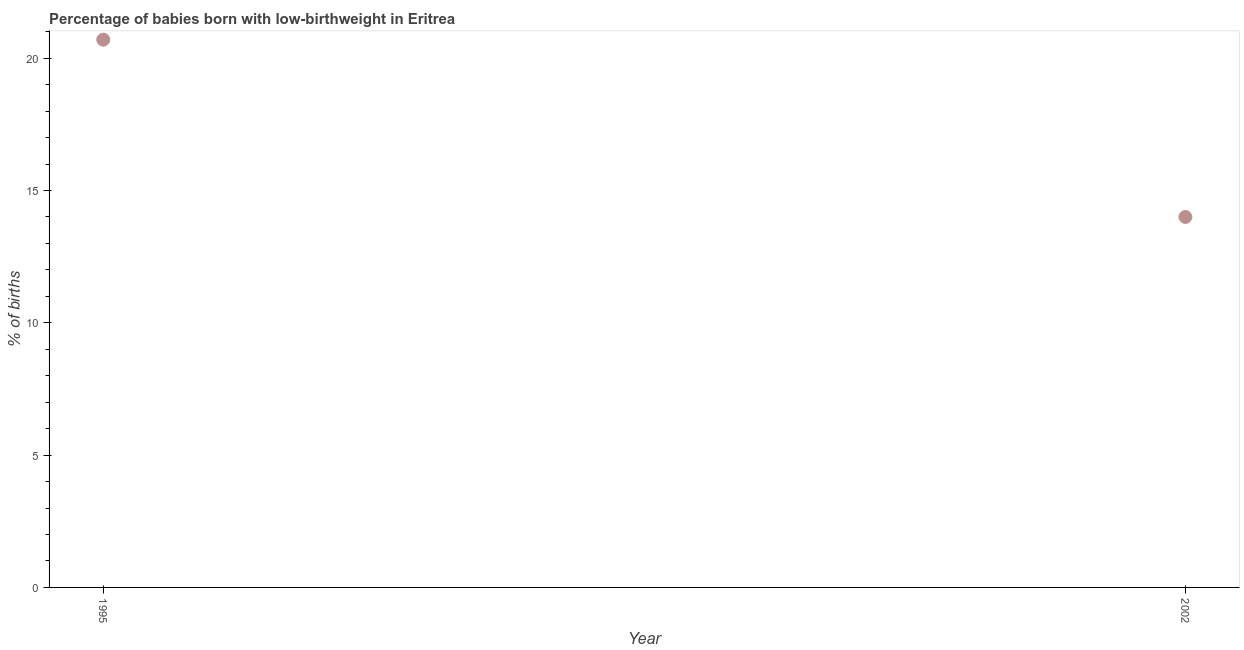What is the percentage of babies who were born with low-birthweight in 1995?
Ensure brevity in your answer.  20.7. Across all years, what is the maximum percentage of babies who were born with low-birthweight?
Offer a very short reply. 20.7. Across all years, what is the minimum percentage of babies who were born with low-birthweight?
Your response must be concise. 14. In which year was the percentage of babies who were born with low-birthweight minimum?
Provide a succinct answer. 2002. What is the sum of the percentage of babies who were born with low-birthweight?
Your response must be concise. 34.7. What is the difference between the percentage of babies who were born with low-birthweight in 1995 and 2002?
Provide a succinct answer. 6.7. What is the average percentage of babies who were born with low-birthweight per year?
Give a very brief answer. 17.35. What is the median percentage of babies who were born with low-birthweight?
Provide a short and direct response. 17.35. In how many years, is the percentage of babies who were born with low-birthweight greater than 11 %?
Provide a succinct answer. 2. Do a majority of the years between 1995 and 2002 (inclusive) have percentage of babies who were born with low-birthweight greater than 16 %?
Provide a short and direct response. No. What is the ratio of the percentage of babies who were born with low-birthweight in 1995 to that in 2002?
Offer a very short reply. 1.48. Is the percentage of babies who were born with low-birthweight in 1995 less than that in 2002?
Provide a succinct answer. No. Does the percentage of babies who were born with low-birthweight monotonically increase over the years?
Ensure brevity in your answer.  No. How many years are there in the graph?
Make the answer very short. 2. What is the difference between two consecutive major ticks on the Y-axis?
Give a very brief answer. 5. Does the graph contain grids?
Ensure brevity in your answer.  No. What is the title of the graph?
Offer a terse response. Percentage of babies born with low-birthweight in Eritrea. What is the label or title of the Y-axis?
Your answer should be very brief. % of births. What is the % of births in 1995?
Give a very brief answer. 20.7. What is the % of births in 2002?
Provide a short and direct response. 14. What is the difference between the % of births in 1995 and 2002?
Offer a terse response. 6.7. What is the ratio of the % of births in 1995 to that in 2002?
Offer a very short reply. 1.48. 